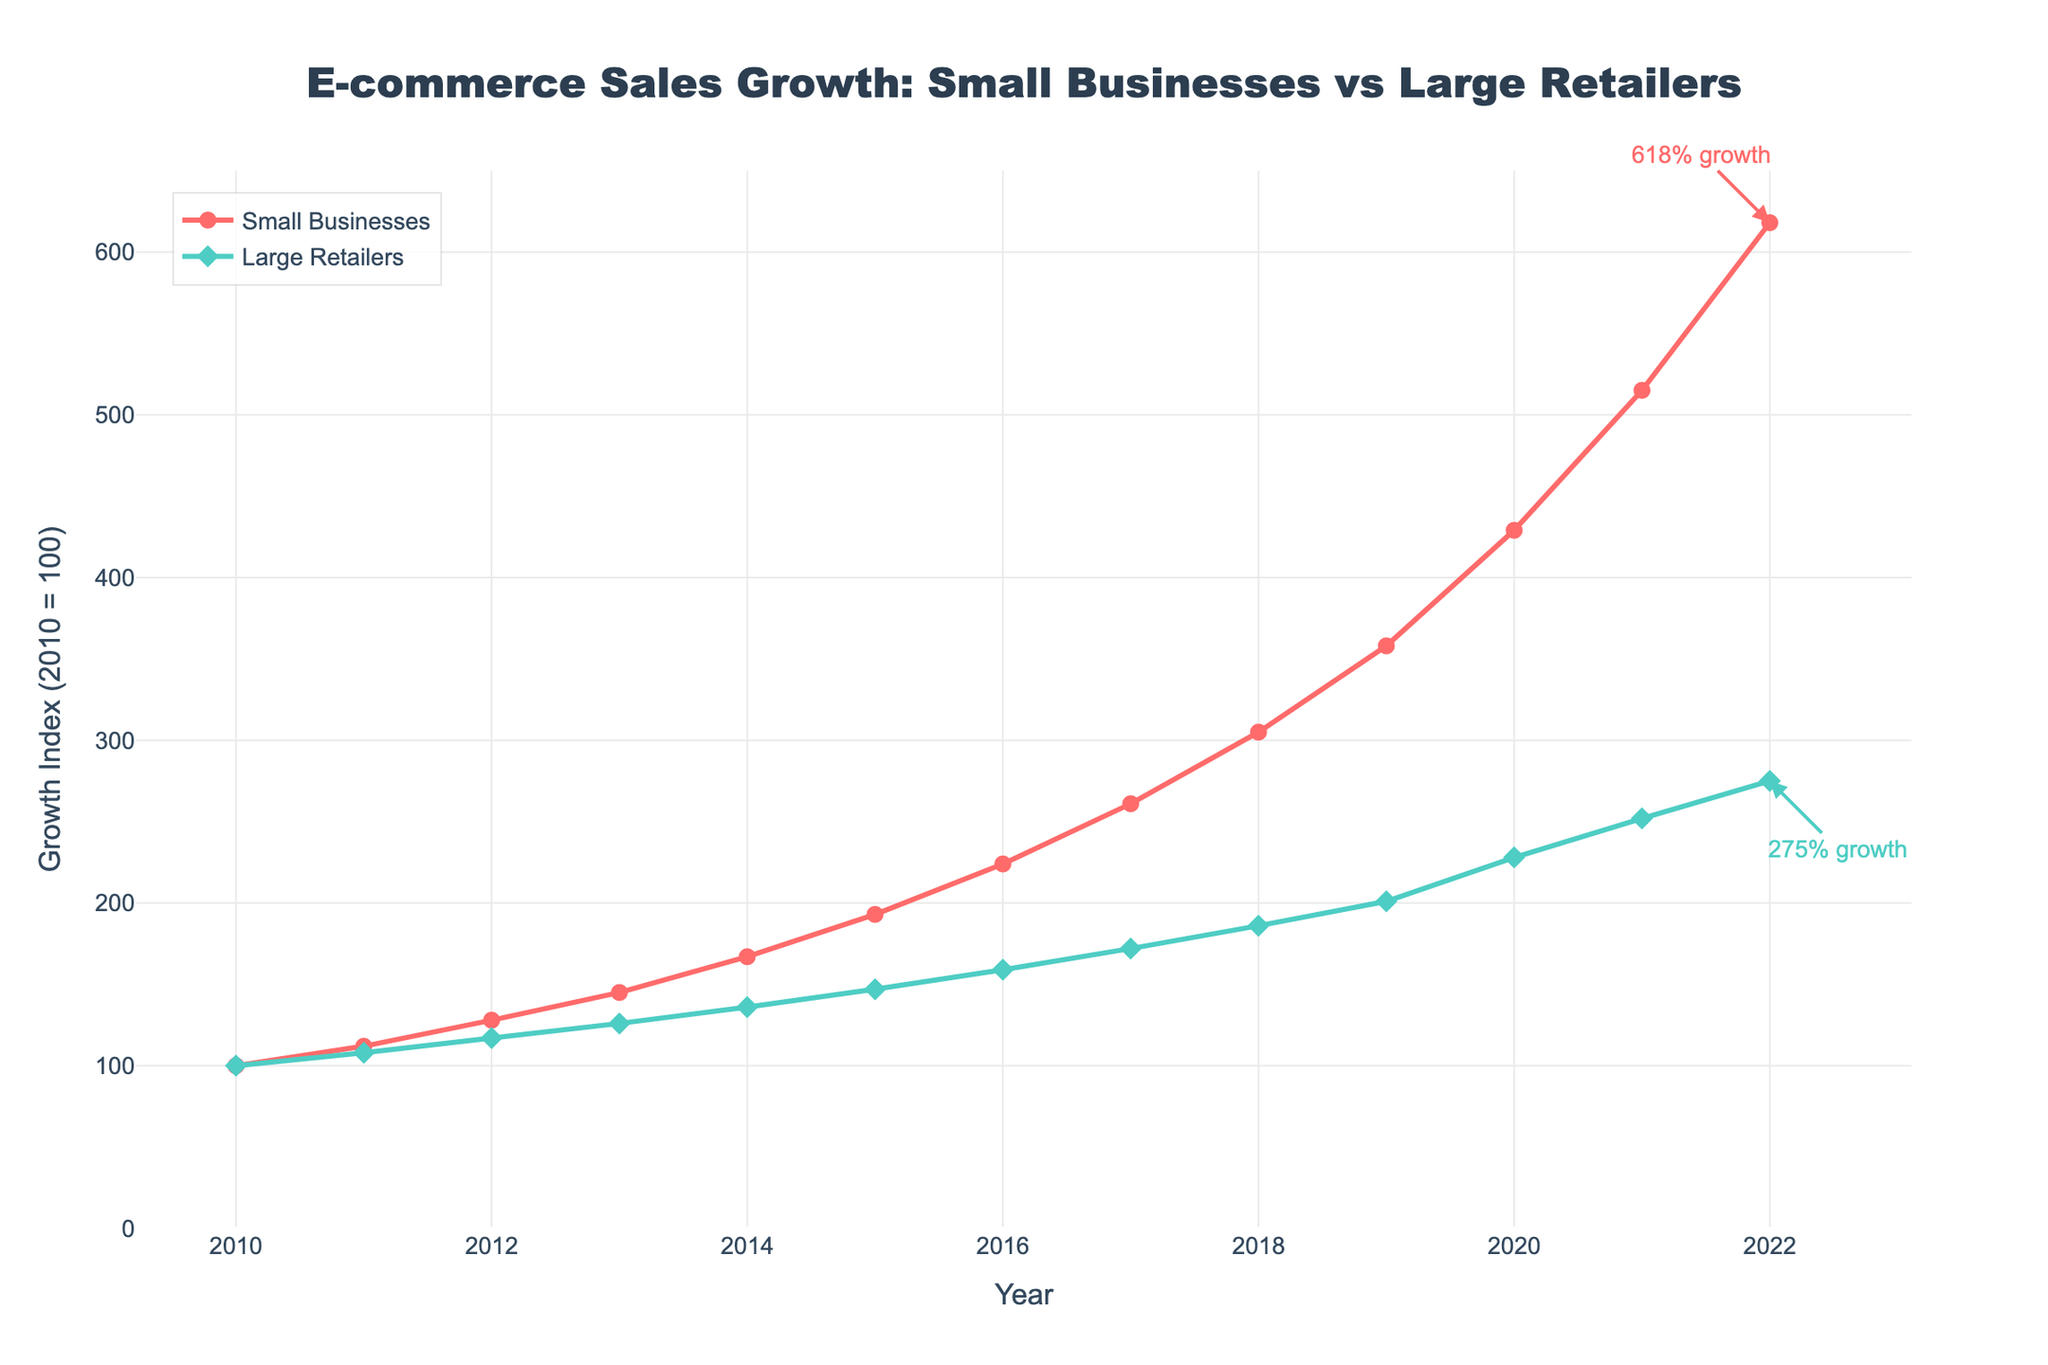What is the growth index of Small Businesses in 2020? Locate the point corresponding to the year 2020 on the x-axis and read the corresponding y-axis value for Small Businesses (red line). The growth index is 429.
Answer: 429 How much higher is the growth index of Small Businesses compared to Large Retailers in 2022? Find the growth index for Small Businesses and Large Retailers in 2022, which are 618 and 275 respectively. Subtract the two values to get the difference: 618 - 275 = 343.
Answer: 343 In which year did Large Retailers surpass a growth index of 200? Look for the first year where the growth index of Large Retailers (green line) exceeds 200. This happens in 2019.
Answer: 2019 What is the average growth index of Small Businesses from 2010 to 2022? Add the growth indices for Small Businesses from 2010 to 2022 and divide by the number of years (13). The sum is (100 + 112 + 128 + 145 + 167 + 193 + 224 + 261 + 305 + 358 + 429 + 515 + 618) = 3555. So, the average is 3555 / 13 ≈ 273.46.
Answer: 273.46 What are the colors representing Small Businesses and Large Retailers in the chart? Identify the lines and markers in the chart: Small Businesses are represented in red, and Large Retailers are in green.
Answer: Red for Small Businesses, Green for Large Retailers Determine the year with the largest year-over-year growth for Small Businesses. Compare the growth index of each year with the previous year for Small Businesses and find the largest increase. The largest increase is from 2020 (429) to 2021 (515), which is 515 - 429 = 86.
Answer: 2021 How many times did the growth index for Small Businesses double since 2010? A doubling means a growth index reaching at least 200% of its previous value. Starting from 100 in 2010, the index doubled by 2016 (224), and doubled again by 2022 (618). So it doubled twice.
Answer: Twice Which year showed the smallest difference in growth index between Small Businesses and Large Retailers? Subtract the Large Retailers' index from Small Businesses' for each year and find the smallest difference. The differences are: 0, 4, 11, 19, 31, 46, 65, 89, 119, 157, 201, 263, 343. The smallest difference is 4 in 2011.
Answer: 2011 